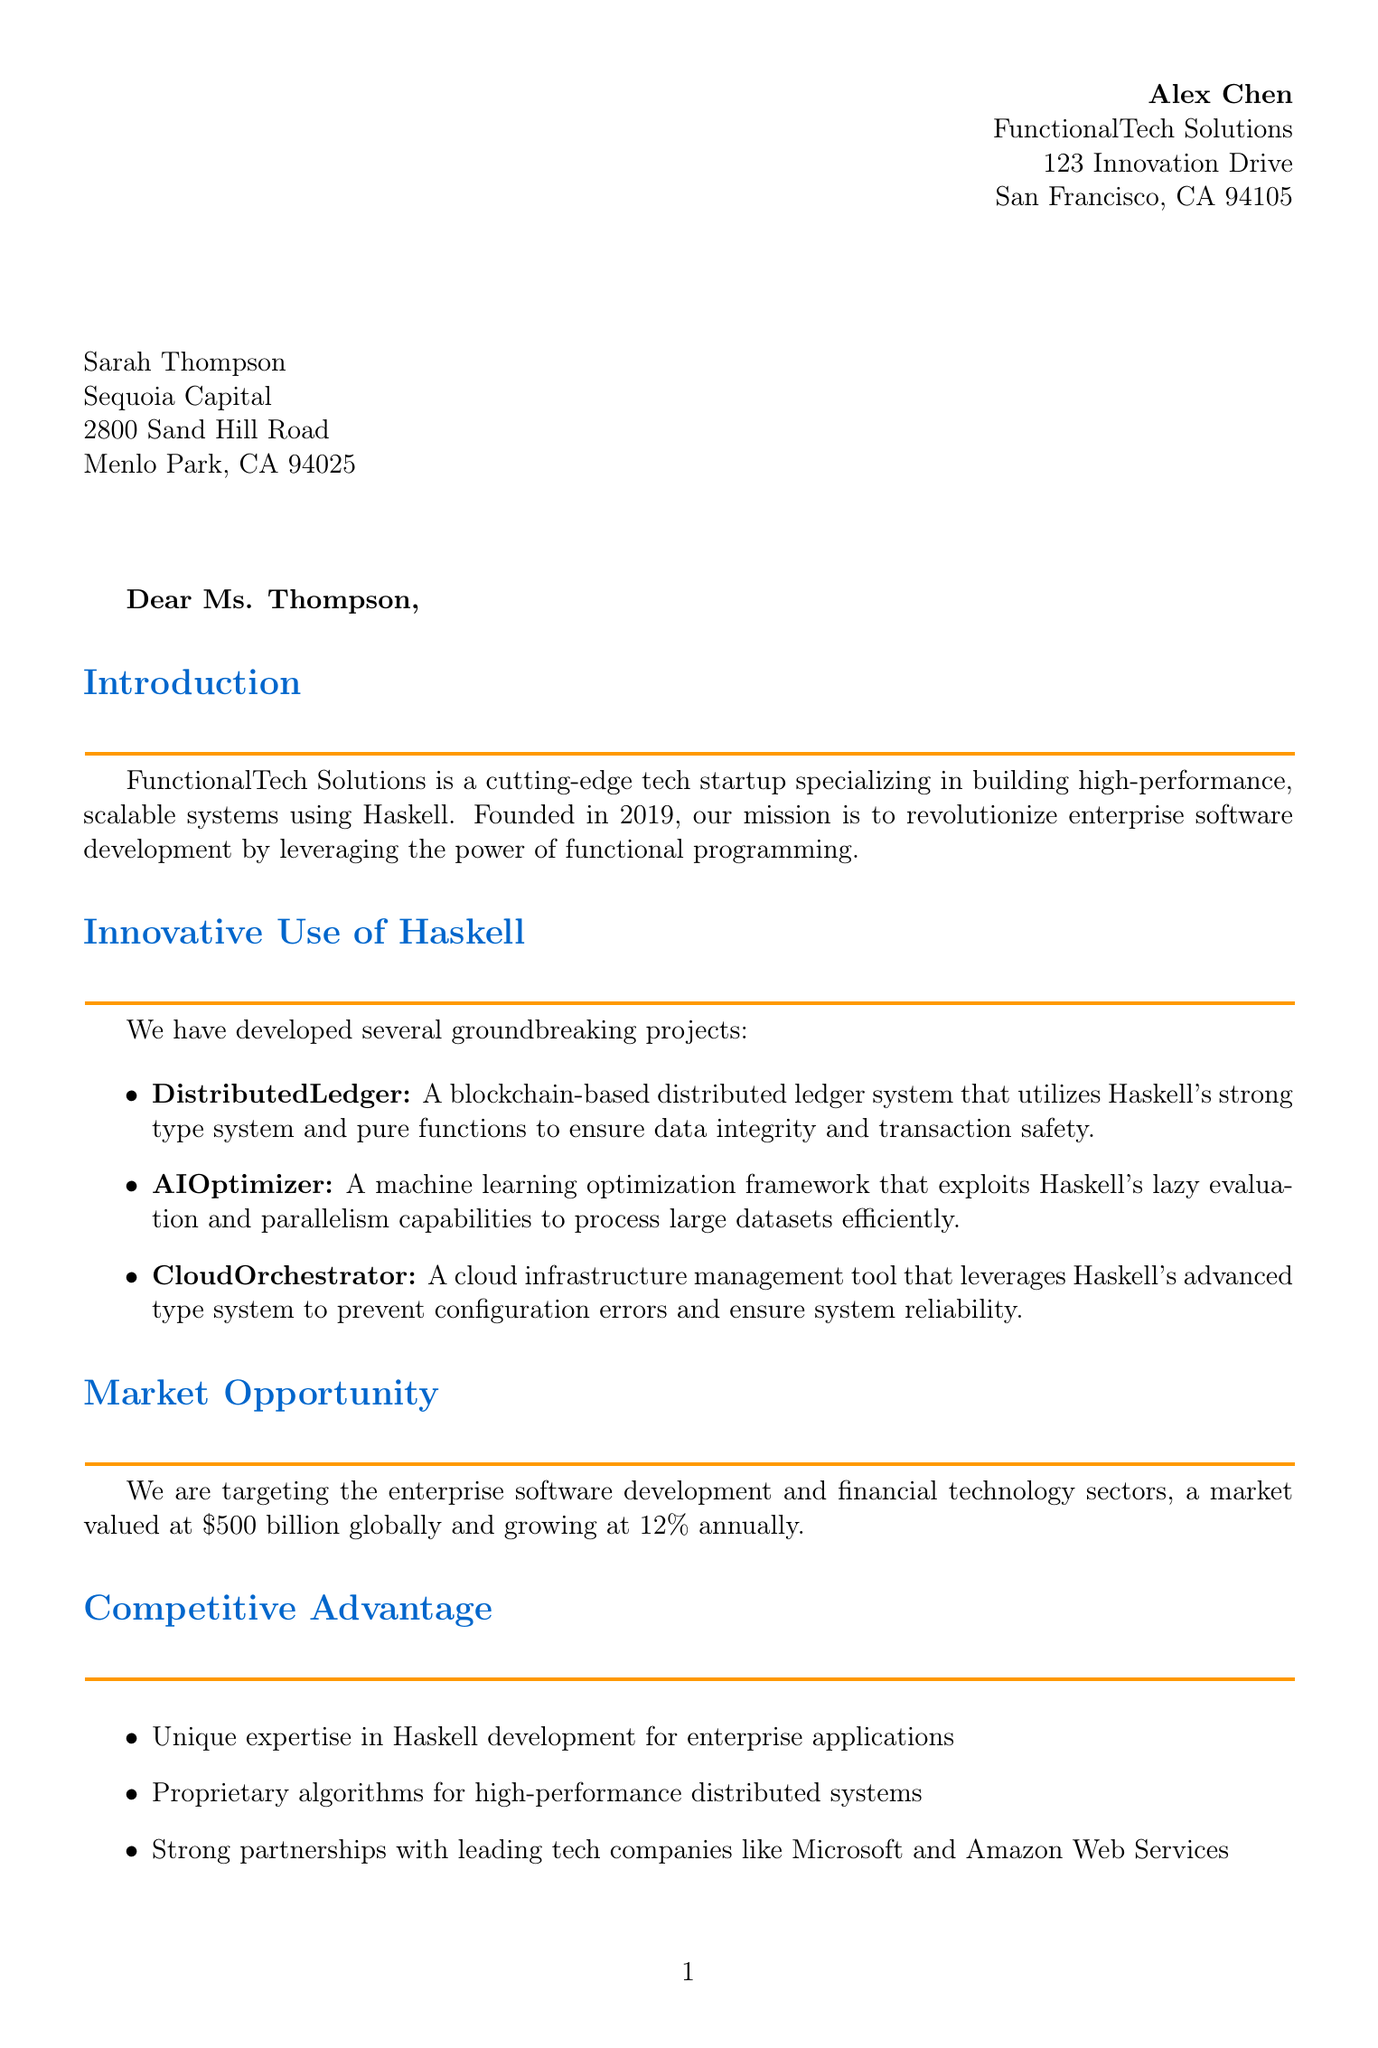What is the name of the startup? The startup's name is explicitly mentioned in the introduction of the letter.
Answer: FunctionalTech Solutions In what year was FunctionalTech Solutions founded? The founding year is clearly stated in the introduction paragraph.
Answer: 2019 Who is the Chief Technology Officer of FunctionalTech Solutions? This information can be found in the team highlights section, which lists key personnel.
Answer: Dr. Emily Wong What is the amount of funding requested in the letter? The funding request section of the letter specifies the amount sought.
Answer: $10 million What is the percentage of equity offered to investors? This information is also provided in the funding request section.
Answer: 15% What is one of the projects utilizing Haskell mentioned in the document? The innovative use of Haskell section lists several projects; one can be cited.
Answer: DistributedLedger What is the primary market opportunity identified by the startup? The document outlines the target market in the market opportunity section.
Answer: Enterprise software development and financial technology sectors What is the expected timeline for profitability? The financial projections section indicates when profitability is expected to be achieved.
Answer: Q4 2024 What is the secondary exit strategy for the startup? The exit strategy section details both primary and secondary exit options.
Answer: Initial Public Offering (IPO) within 5-7 years 